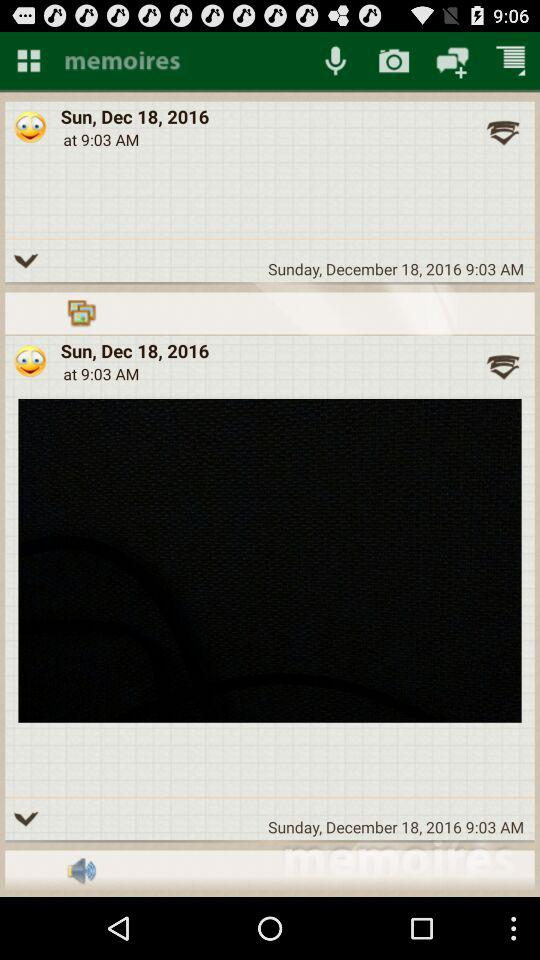What 's the date? The date is Sunday, December 18, 2016. 